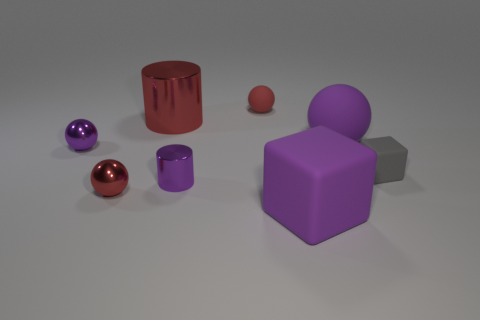Is the color of the large cylinder the same as the tiny rubber ball?
Your response must be concise. Yes. Is there anything else of the same color as the big rubber sphere?
Keep it short and to the point. Yes. There is a ball to the right of the red rubber object; is it the same color as the tiny metal cylinder that is in front of the small purple sphere?
Provide a succinct answer. Yes. How many other things are there of the same material as the purple cylinder?
Provide a short and direct response. 3. There is a large metal cylinder; does it have the same color as the small object that is behind the red metallic cylinder?
Provide a short and direct response. Yes. What number of cyan things are cubes or tiny rubber cubes?
Your answer should be very brief. 0. There is a small purple thing that is to the right of the shiny cylinder that is behind the gray block; are there any red metal balls that are in front of it?
Your answer should be compact. Yes. Are there fewer small balls than metallic things?
Keep it short and to the point. Yes. Is the shape of the small metal object to the right of the red metallic ball the same as  the large red metal object?
Keep it short and to the point. Yes. Are any cubes visible?
Your answer should be compact. Yes. 